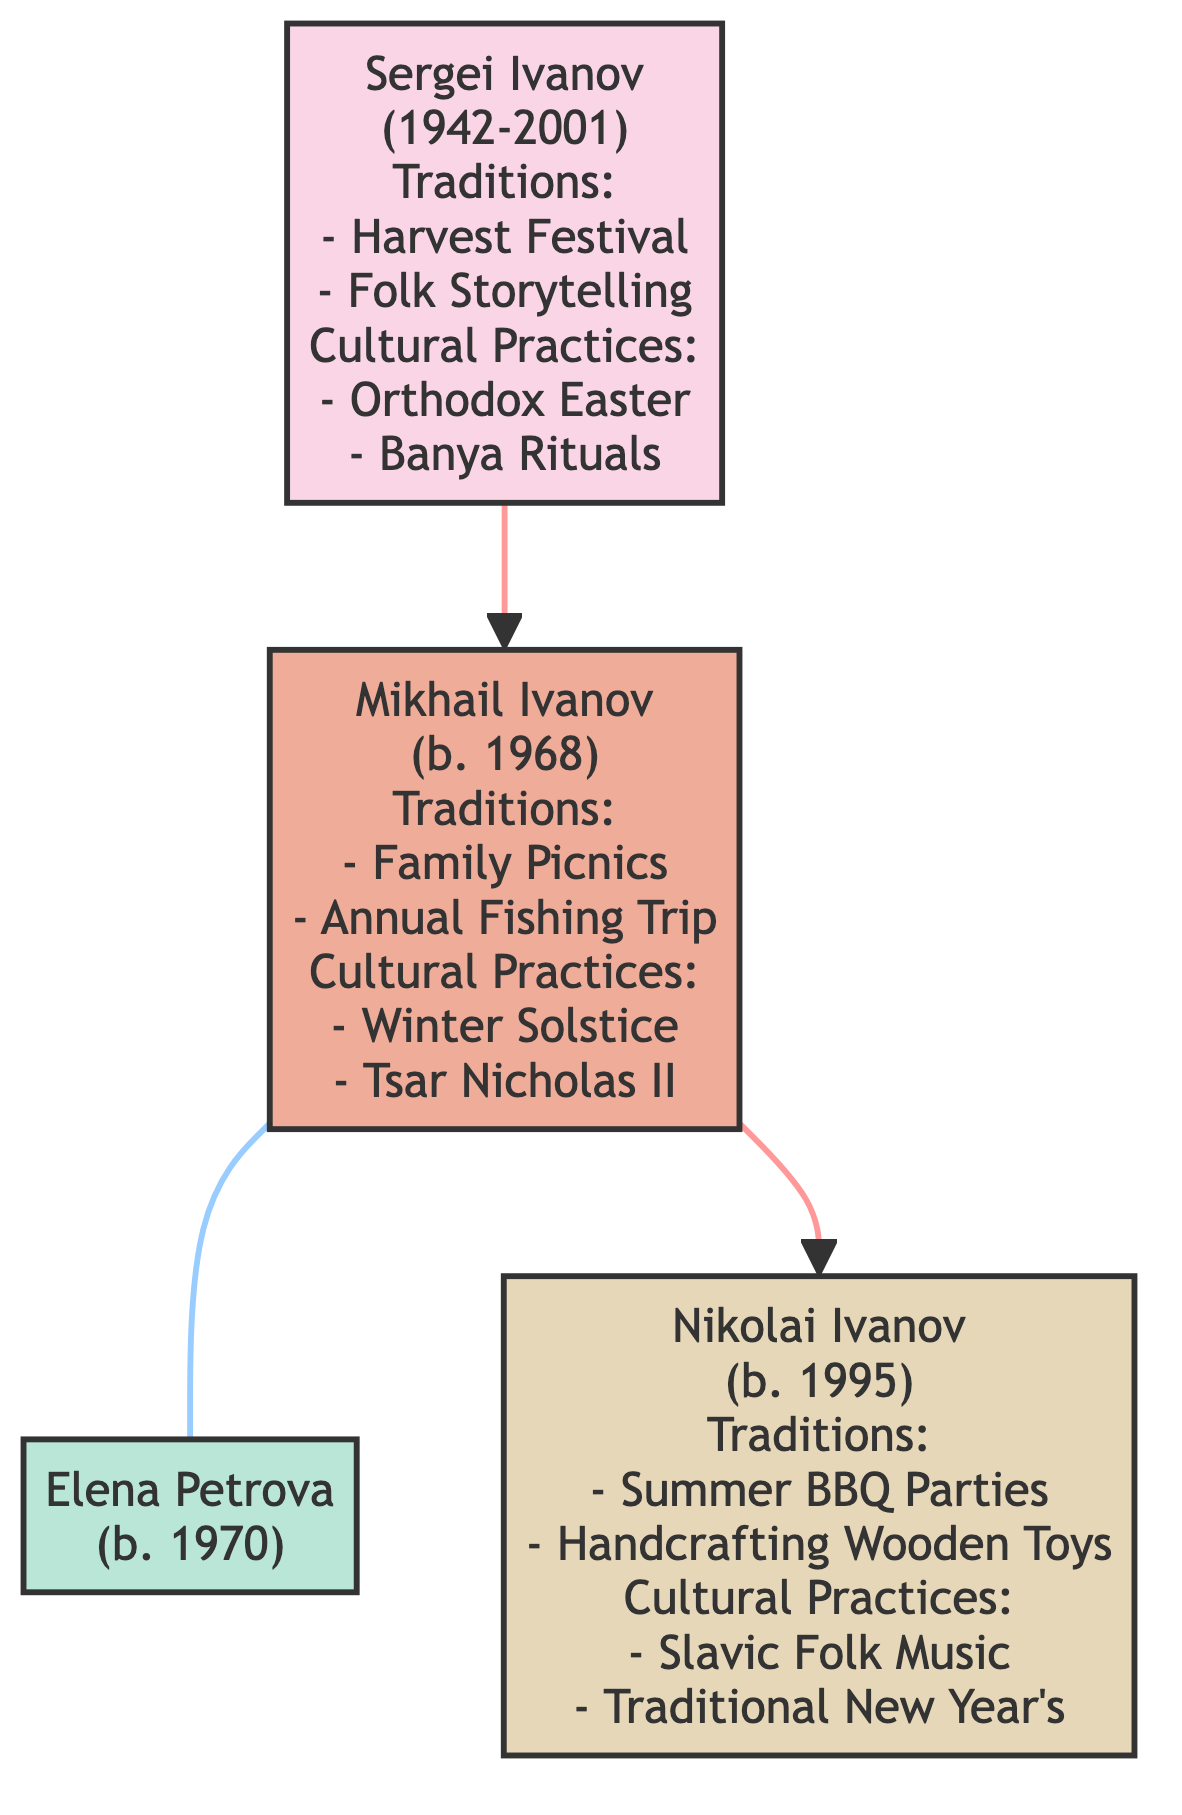What is the name of the eldest family member? The diagram indicates that Sergei Ivanov is the eldest family member, as he is listed first and has a birth year of 1942.
Answer: Sergei Ivanov In which year was Mikhail Ivanov born? The diagram shows that Mikhail Ivanov was born in 1968, as stated next to his name.
Answer: 1968 How many traditions does Nikolai Ivanov have listed? By examining Nikolai Ivanov's section in the diagram, we see that he has two traditions listed: Summer BBQ Parties and Handcrafting Wooden Toys with Elders.
Answer: 2 What cultural practice connects both Mikhail Ivanov and his son, Nikolai? The cultural practices section for Mikhail lists the Winter Solstice Gathering, while Nikolai's section includes Slavic Folk Music Sessions and Traditional New Year's Eve Celebrations. The commonality here is that they both celebrate family-related cultural practices but aren't directly linked by a single practice. There is no direct answer; they are separate cultural practices.
Answer: None What relationship exists between Mikhail Ivanov and Elena Petrova? The diagram indicates that Mikhail is married to Elena Petrova, shown by the connection indicated through a marriage line between them in the family tree.
Answer: Spouse How many generations are represented in the family tree? The diagram consists of three generations: generation1 with Sergei, generation2 with Mikhail and Elena, and generation3 with Nikolai. Counting them gives us three distinct generations.
Answer: 3 List one of the cultural practices from Sergei Ivanov’s generation. Looking at Sergei Ivanov's section, we find cultural practices such as the Orthodox Easter Celebration or Banya Rituals. Any one of these can be considered.
Answer: Orthodox Easter Celebration What do Mikhail Ivanov and Nikolai Ivanov have in common regarding traditions? By reviewing their sections, Mikhail’s traditions include Family Picnics in Nature and Annual Fishing Trip, while Nikolai's traditions are Summer BBQ Parties and Handcrafting Wooden Toys. They do not have any similar traditions directly, but both have family-oriented traditions.
Answer: None 